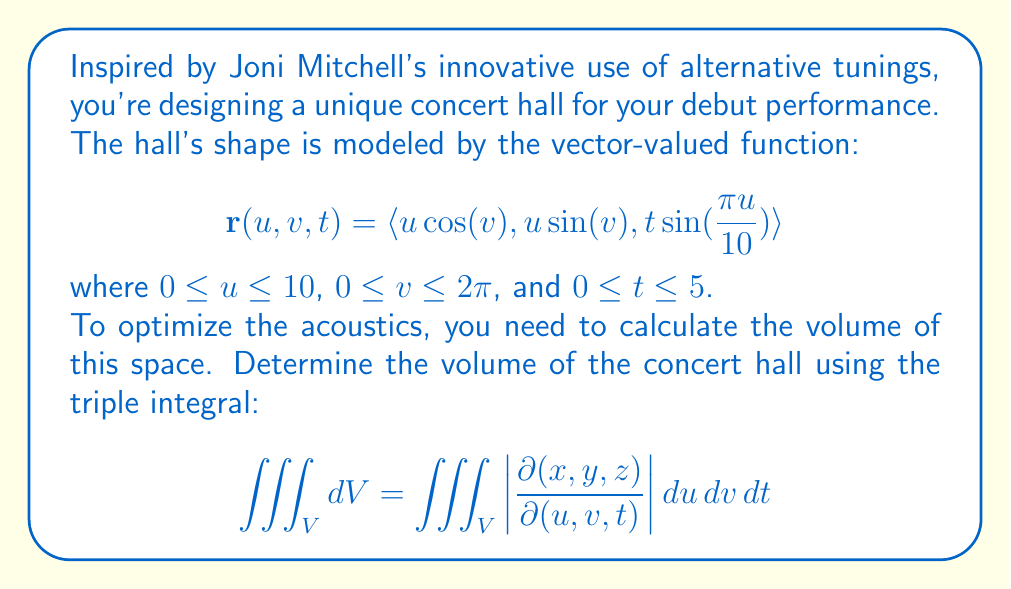Can you solve this math problem? Let's approach this step-by-step:

1) First, we need to calculate the Jacobian determinant $\left|\frac{\partial(x,y,z)}{\partial(u,v,t)}\right|$:

   $$\left|\frac{\partial(x,y,z)}{\partial(u,v,t)}\right| = \begin{vmatrix}
   \frac{\partial x}{\partial u} & \frac{\partial x}{\partial v} & \frac{\partial x}{\partial t} \\
   \frac{\partial y}{\partial u} & \frac{\partial y}{\partial v} & \frac{\partial y}{\partial t} \\
   \frac{\partial z}{\partial u} & \frac{\partial z}{\partial v} & \frac{\partial z}{\partial t}
   \end{vmatrix}$$

2) Calculating the partial derivatives:
   
   $\frac{\partial x}{\partial u} = \cos(v)$, $\frac{\partial x}{\partial v} = -u\sin(v)$, $\frac{\partial x}{\partial t} = 0$
   
   $\frac{\partial y}{\partial u} = \sin(v)$, $\frac{\partial y}{\partial v} = u\cos(v)$, $\frac{\partial y}{\partial t} = 0$
   
   $\frac{\partial z}{\partial u} = \frac{\pi t}{10}\cos(\frac{\pi u}{10})$, $\frac{\partial z}{\partial v} = 0$, $\frac{\partial z}{\partial t} = \sin(\frac{\pi u}{10})$

3) Substituting into the determinant:

   $$\left|\frac{\partial(x,y,z)}{\partial(u,v,t)}\right| = \begin{vmatrix}
   \cos(v) & -u\sin(v) & 0 \\
   \sin(v) & u\cos(v) & 0 \\
   \frac{\pi t}{10}\cos(\frac{\pi u}{10}) & 0 & \sin(\frac{\pi u}{10})
   \end{vmatrix}$$

4) Evaluating the determinant:

   $$\left|\frac{\partial(x,y,z)}{\partial(u,v,t)}\right| = u\sin(\frac{\pi u}{10})$$

5) Now we can set up the triple integral:

   $$V = \iiint_V dV = \int_0^5 \int_0^{2\pi} \int_0^{10} u\sin(\frac{\pi u}{10}) \, du \, dv \, dt$$

6) Integrating with respect to $v$:

   $$V = \int_0^5 \int_0^{10} 2\pi u\sin(\frac{\pi u}{10}) \, du \, dt$$

7) Integrating with respect to $u$ (using integration by parts):

   $$V = \int_0^5 2\pi \left[-\frac{100}{\pi}\cos(\frac{\pi u}{10})\right]_0^{10} \, dt = \int_0^5 200\pi \, dt$$

8) Finally, integrating with respect to $t$:

   $$V = 200\pi \cdot 5 = 1000\pi$$

Thus, the volume of the concert hall is $1000\pi$ cubic units.
Answer: $1000\pi$ cubic units 